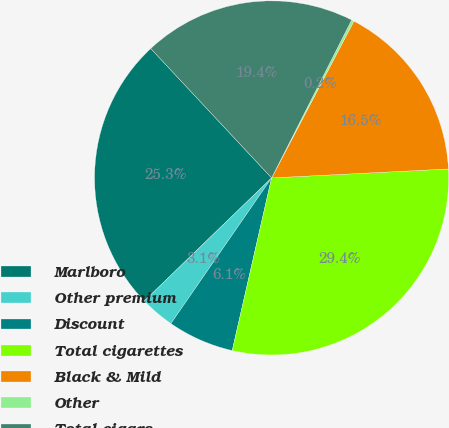Convert chart. <chart><loc_0><loc_0><loc_500><loc_500><pie_chart><fcel>Marlboro<fcel>Other premium<fcel>Discount<fcel>Total cigarettes<fcel>Black & Mild<fcel>Other<fcel>Total cigars<nl><fcel>25.27%<fcel>3.14%<fcel>6.06%<fcel>29.37%<fcel>16.5%<fcel>0.23%<fcel>19.42%<nl></chart> 